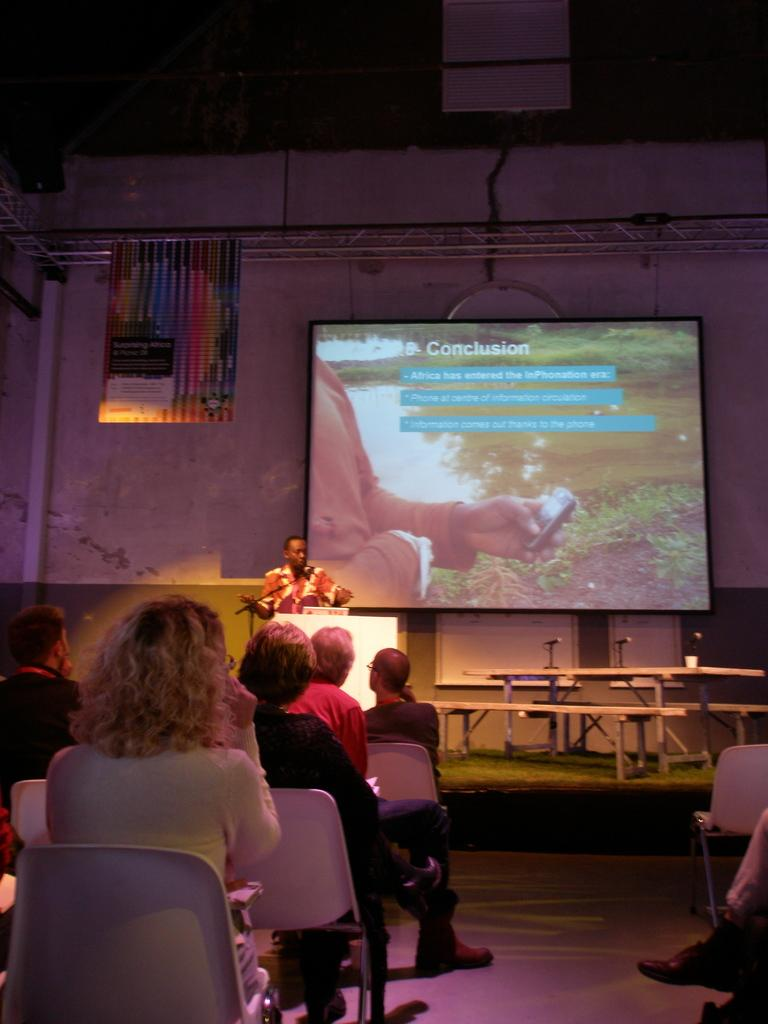What are the people in the image doing? The people in the image are sitting on chairs. What can be seen on the screen in the image? The facts do not provide information about the screen's content. What is the position of the person standing in the image? The facts do not specify the person's position. What is the background of the image? There is a wall in the image, which serves as the background. Are there any cobwebs visible on the wall in the image? There is no mention of cobwebs in the provided facts, so we cannot determine if any are present in the image. 